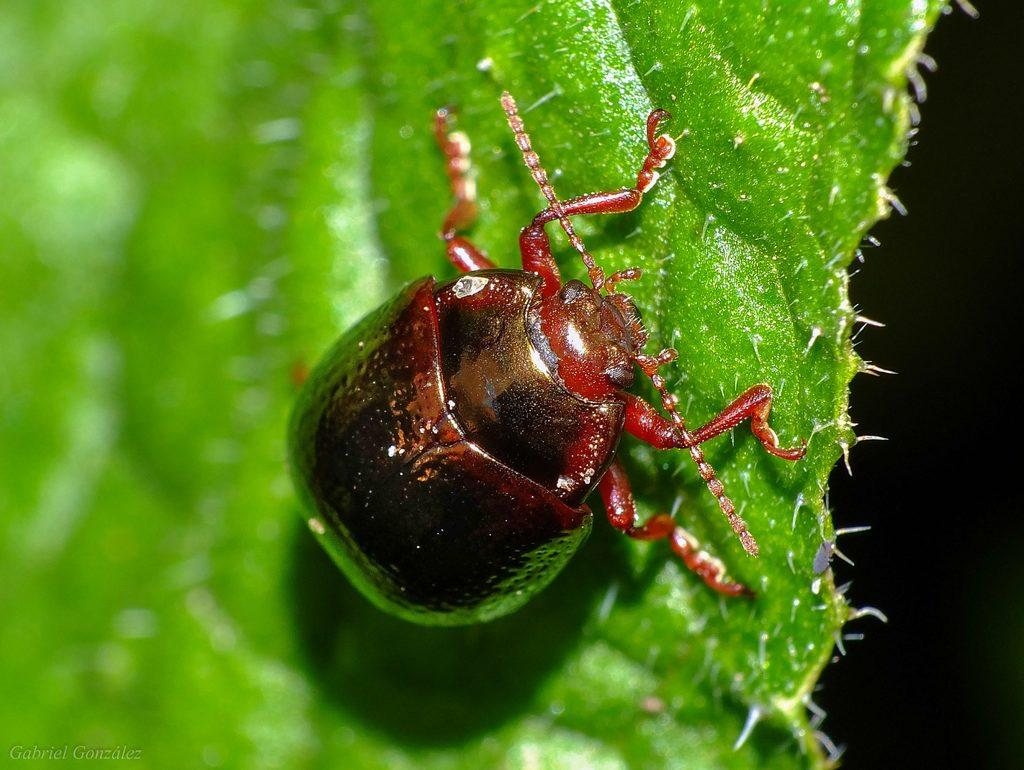What type of insect is in the image? There is a brown color insect in the image. Where is the insect located? The insect is on a leaf. Can you describe the leaf in the image? The leaf has thorns. What type of cream is being used to fix the carriage in the image? There is no cream or carriage present in the image; it features a brown color insect on a leaf with thorns. Can you tell me where the wrench is located in the image? There is no wrench present in the image. 